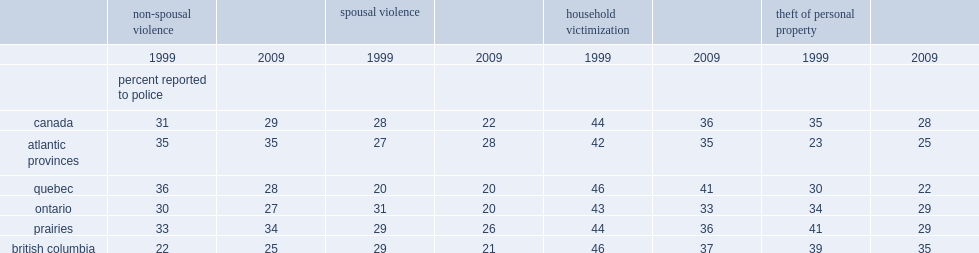What was the percentage of spousal violence victims reported to police dropped over this ten-year period in ontario? 11. Which had a lower rate of theft of personal property in 2009, quebec or canada? Quebec. 